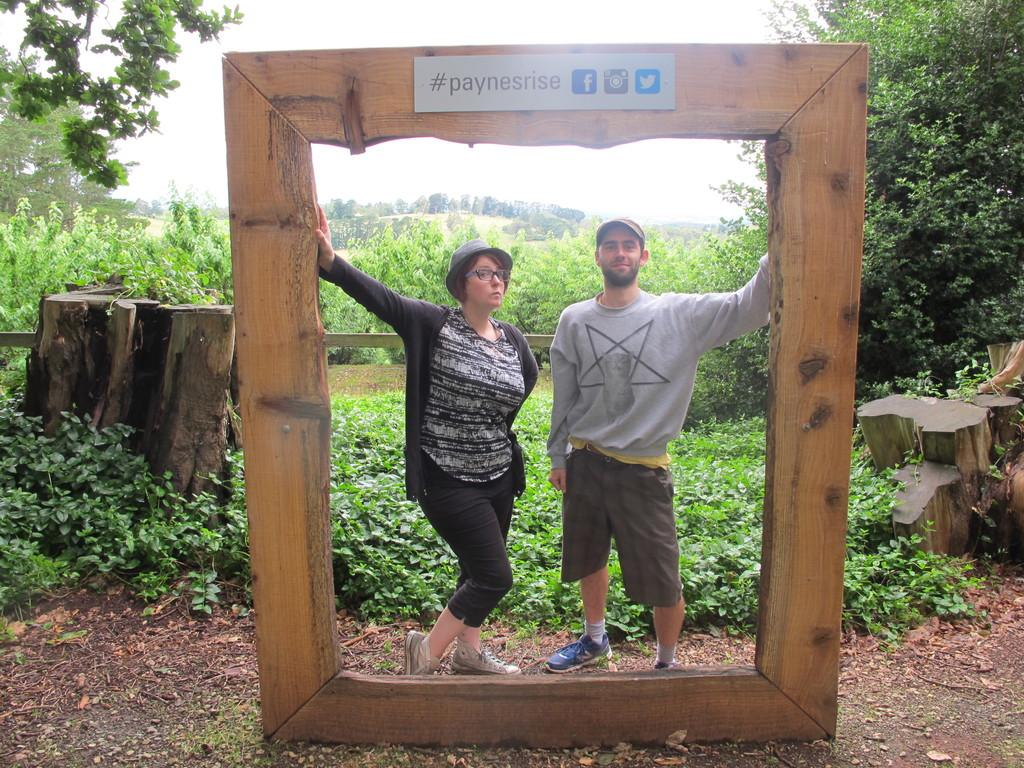How many people are present in the image? There are two people, a man and a woman, present in the image. What are the man and the woman wearing on their heads? Both the man and the woman are wearing caps in the image. What can be seen in the background of the image? There are plants and trees visible in the background of the image. How many legs does the badge have in the image? There is no badge present in the image, so it is not possible to determine how many legs it might have. 